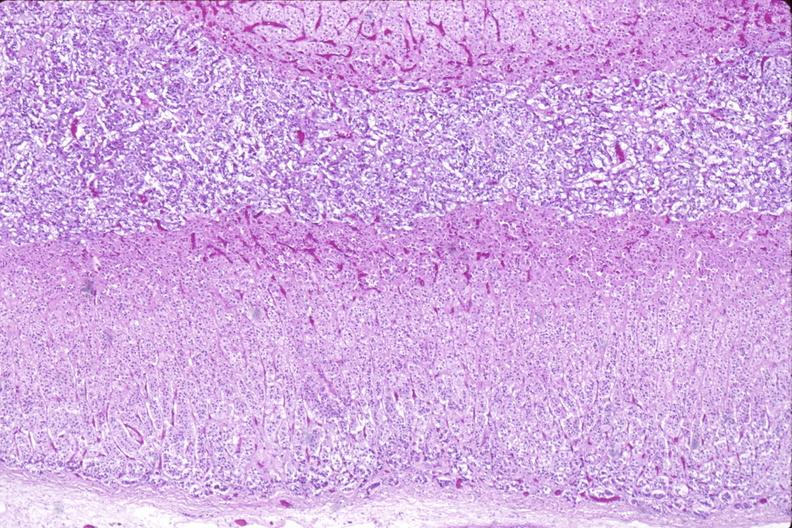what does this image show?
Answer the question using a single word or phrase. Adrenal gland 